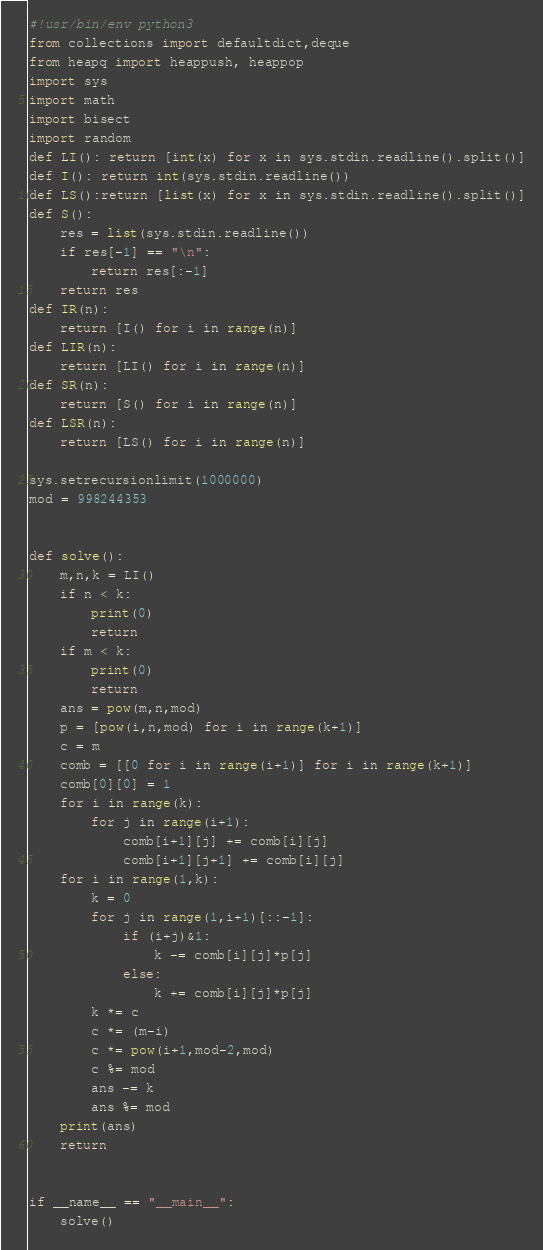<code> <loc_0><loc_0><loc_500><loc_500><_Python_>#!usr/bin/env python3
from collections import defaultdict,deque
from heapq import heappush, heappop
import sys
import math
import bisect
import random
def LI(): return [int(x) for x in sys.stdin.readline().split()]
def I(): return int(sys.stdin.readline())
def LS():return [list(x) for x in sys.stdin.readline().split()]
def S():
    res = list(sys.stdin.readline())
    if res[-1] == "\n":
        return res[:-1]
    return res
def IR(n):
    return [I() for i in range(n)]
def LIR(n):
    return [LI() for i in range(n)]
def SR(n):
    return [S() for i in range(n)]
def LSR(n):
    return [LS() for i in range(n)]

sys.setrecursionlimit(1000000)
mod = 998244353


def solve():
    m,n,k = LI()
    if n < k:
        print(0)
        return
    if m < k:
        print(0)
        return
    ans = pow(m,n,mod)
    p = [pow(i,n,mod) for i in range(k+1)]
    c = m
    comb = [[0 for i in range(i+1)] for i in range(k+1)]
    comb[0][0] = 1
    for i in range(k):
        for j in range(i+1):
            comb[i+1][j] += comb[i][j]
            comb[i+1][j+1] += comb[i][j]
    for i in range(1,k):
        k = 0
        for j in range(1,i+1)[::-1]:
            if (i+j)&1:
                k -= comb[i][j]*p[j]
            else:
                k += comb[i][j]*p[j]
        k *= c
        c *= (m-i)
        c *= pow(i+1,mod-2,mod)
        c %= mod
        ans -= k
        ans %= mod
    print(ans)
    return


if __name__ == "__main__":
    solve()

</code> 